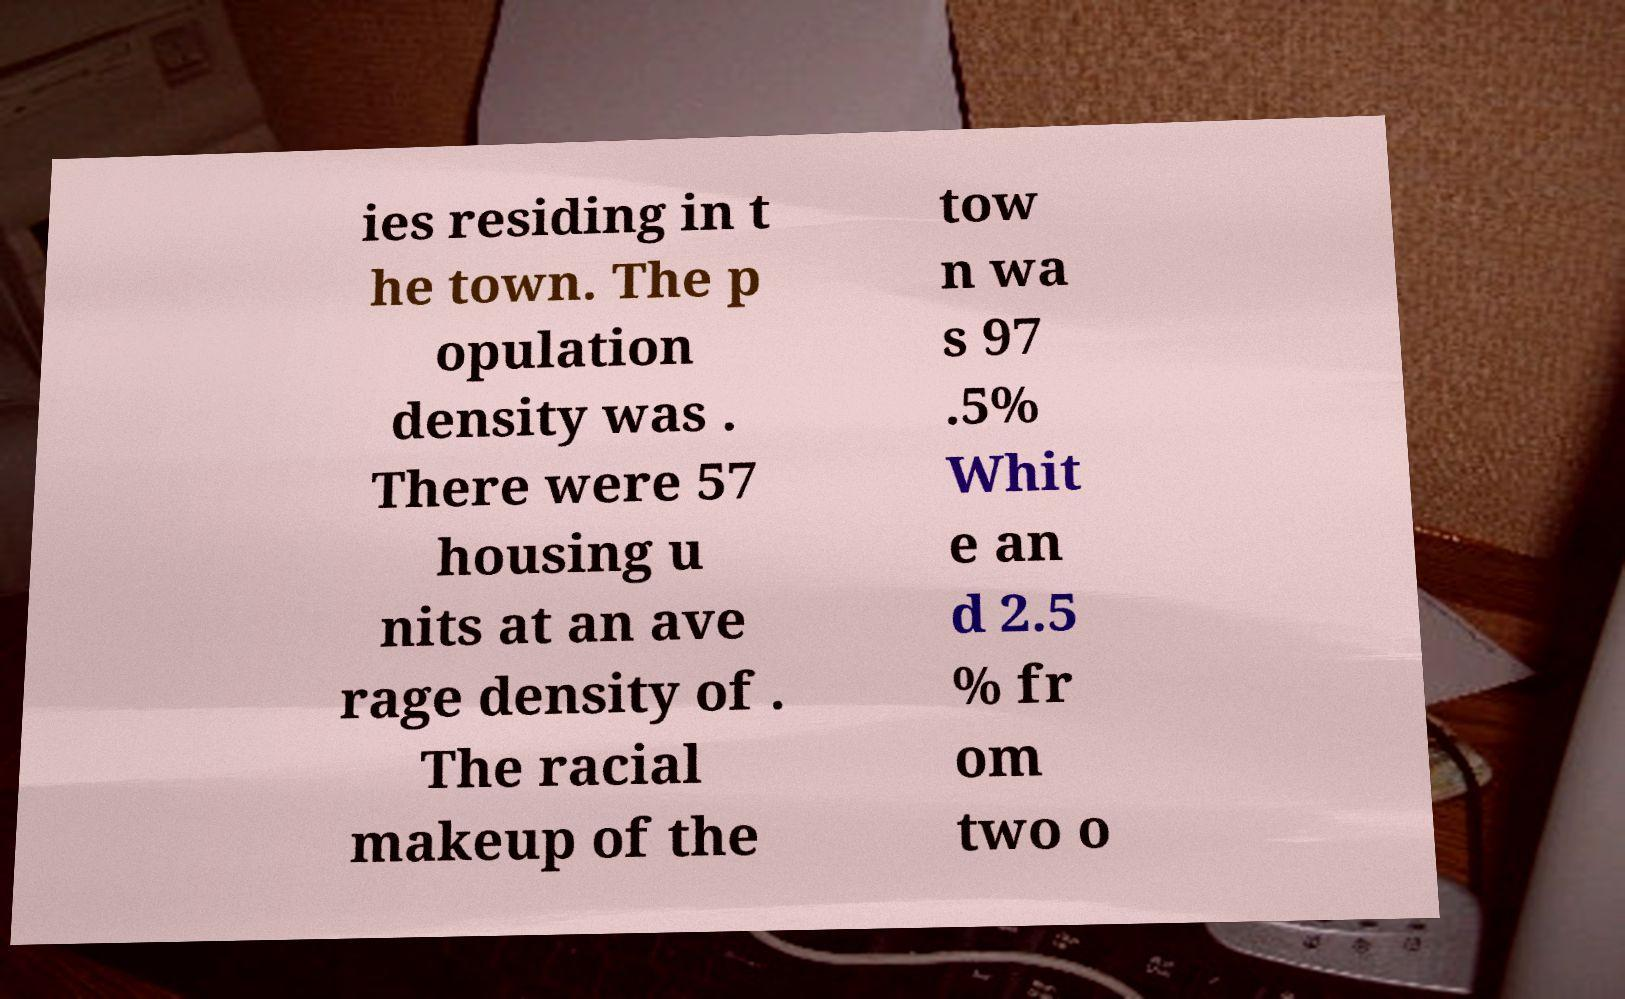Could you extract and type out the text from this image? ies residing in t he town. The p opulation density was . There were 57 housing u nits at an ave rage density of . The racial makeup of the tow n wa s 97 .5% Whit e an d 2.5 % fr om two o 